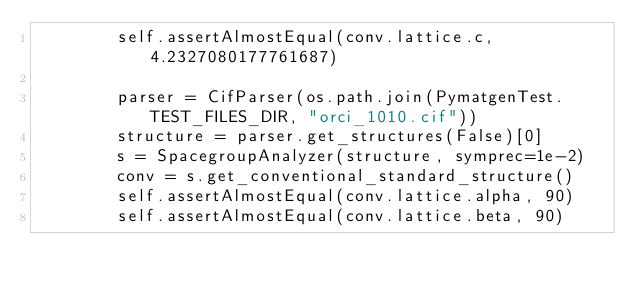<code> <loc_0><loc_0><loc_500><loc_500><_Python_>        self.assertAlmostEqual(conv.lattice.c, 4.2327080177761687)

        parser = CifParser(os.path.join(PymatgenTest.TEST_FILES_DIR, "orci_1010.cif"))
        structure = parser.get_structures(False)[0]
        s = SpacegroupAnalyzer(structure, symprec=1e-2)
        conv = s.get_conventional_standard_structure()
        self.assertAlmostEqual(conv.lattice.alpha, 90)
        self.assertAlmostEqual(conv.lattice.beta, 90)</code> 